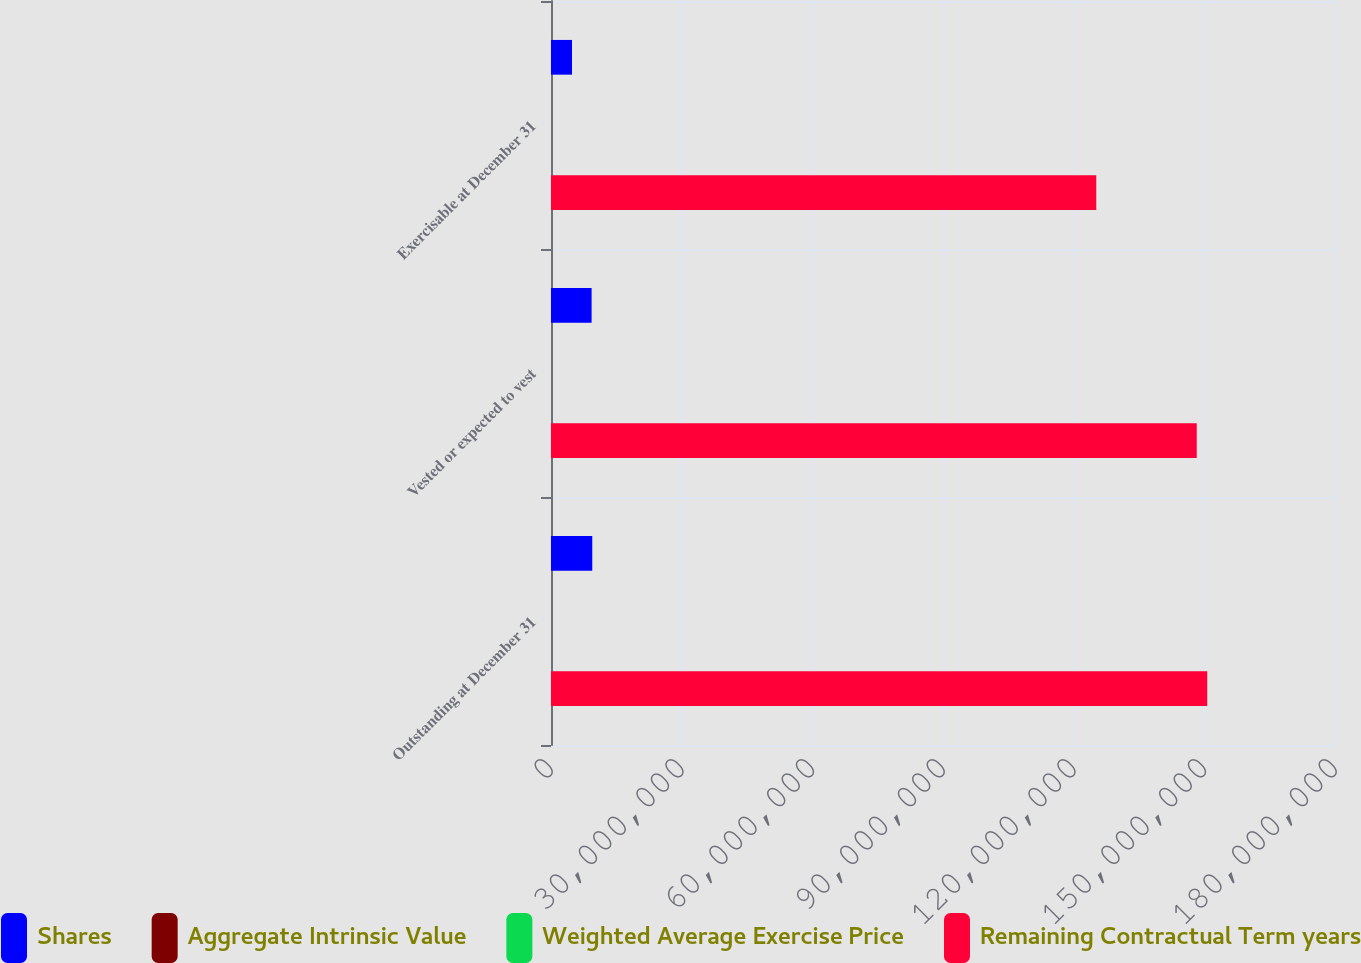<chart> <loc_0><loc_0><loc_500><loc_500><stacked_bar_chart><ecel><fcel>Outstanding at December 31<fcel>Vested or expected to vest<fcel>Exercisable at December 31<nl><fcel>Shares<fcel>9.47348e+06<fcel>9.32191e+06<fcel>4.82333e+06<nl><fcel>Aggregate Intrinsic Value<fcel>58.69<fcel>58.69<fcel>43.99<nl><fcel>Weighted Average Exercise Price<fcel>6.86<fcel>6.86<fcel>5.38<nl><fcel>Remaining Contractual Term years<fcel>1.50667e+08<fcel>1.48256e+08<fcel>1.25192e+08<nl></chart> 